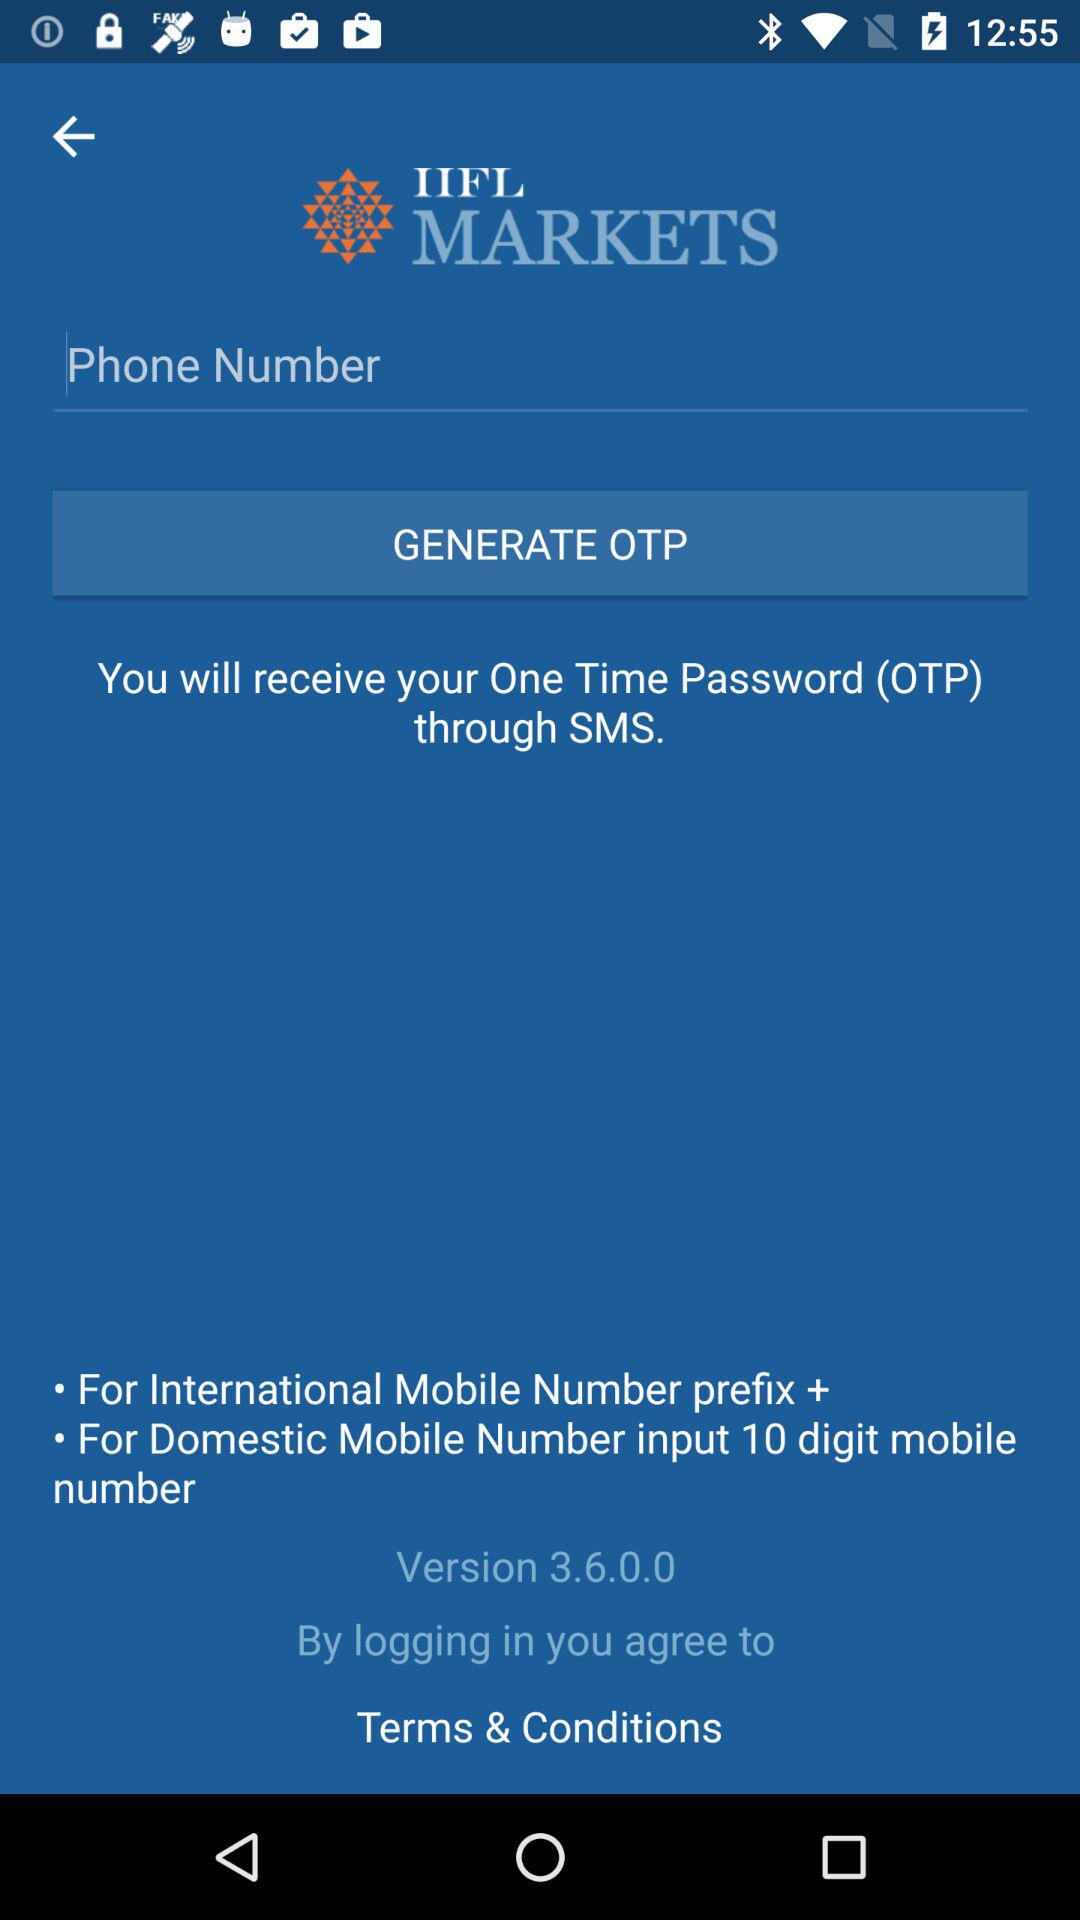What is the prefix for the international mobile number? The prefix for the international mobile number is "+". 